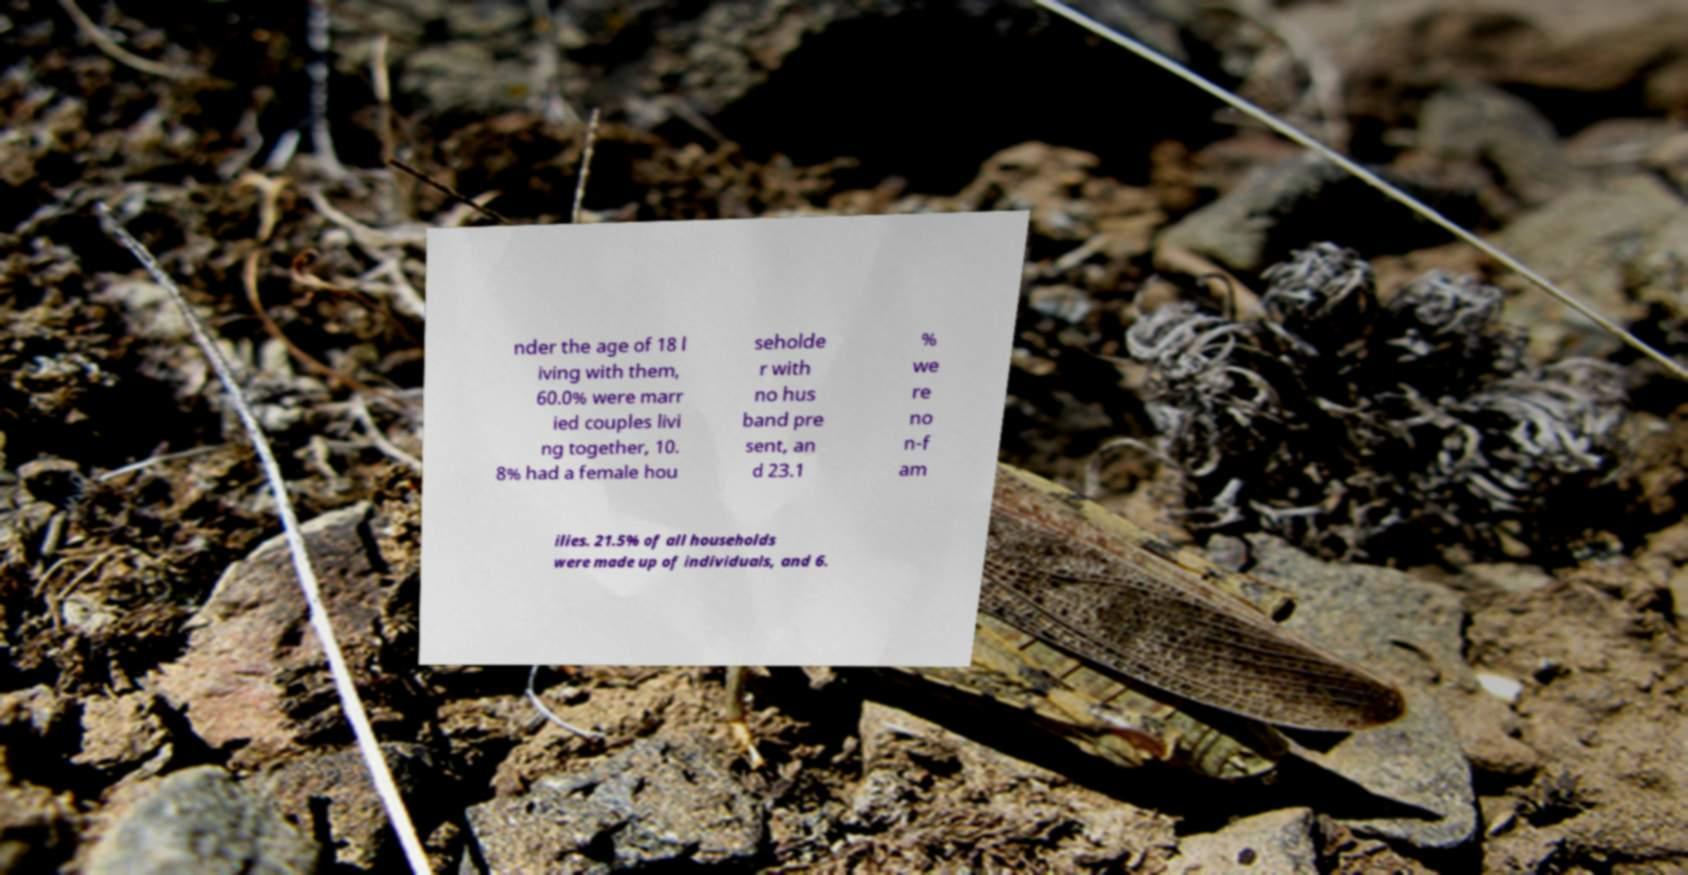I need the written content from this picture converted into text. Can you do that? nder the age of 18 l iving with them, 60.0% were marr ied couples livi ng together, 10. 8% had a female hou seholde r with no hus band pre sent, an d 23.1 % we re no n-f am ilies. 21.5% of all households were made up of individuals, and 6. 